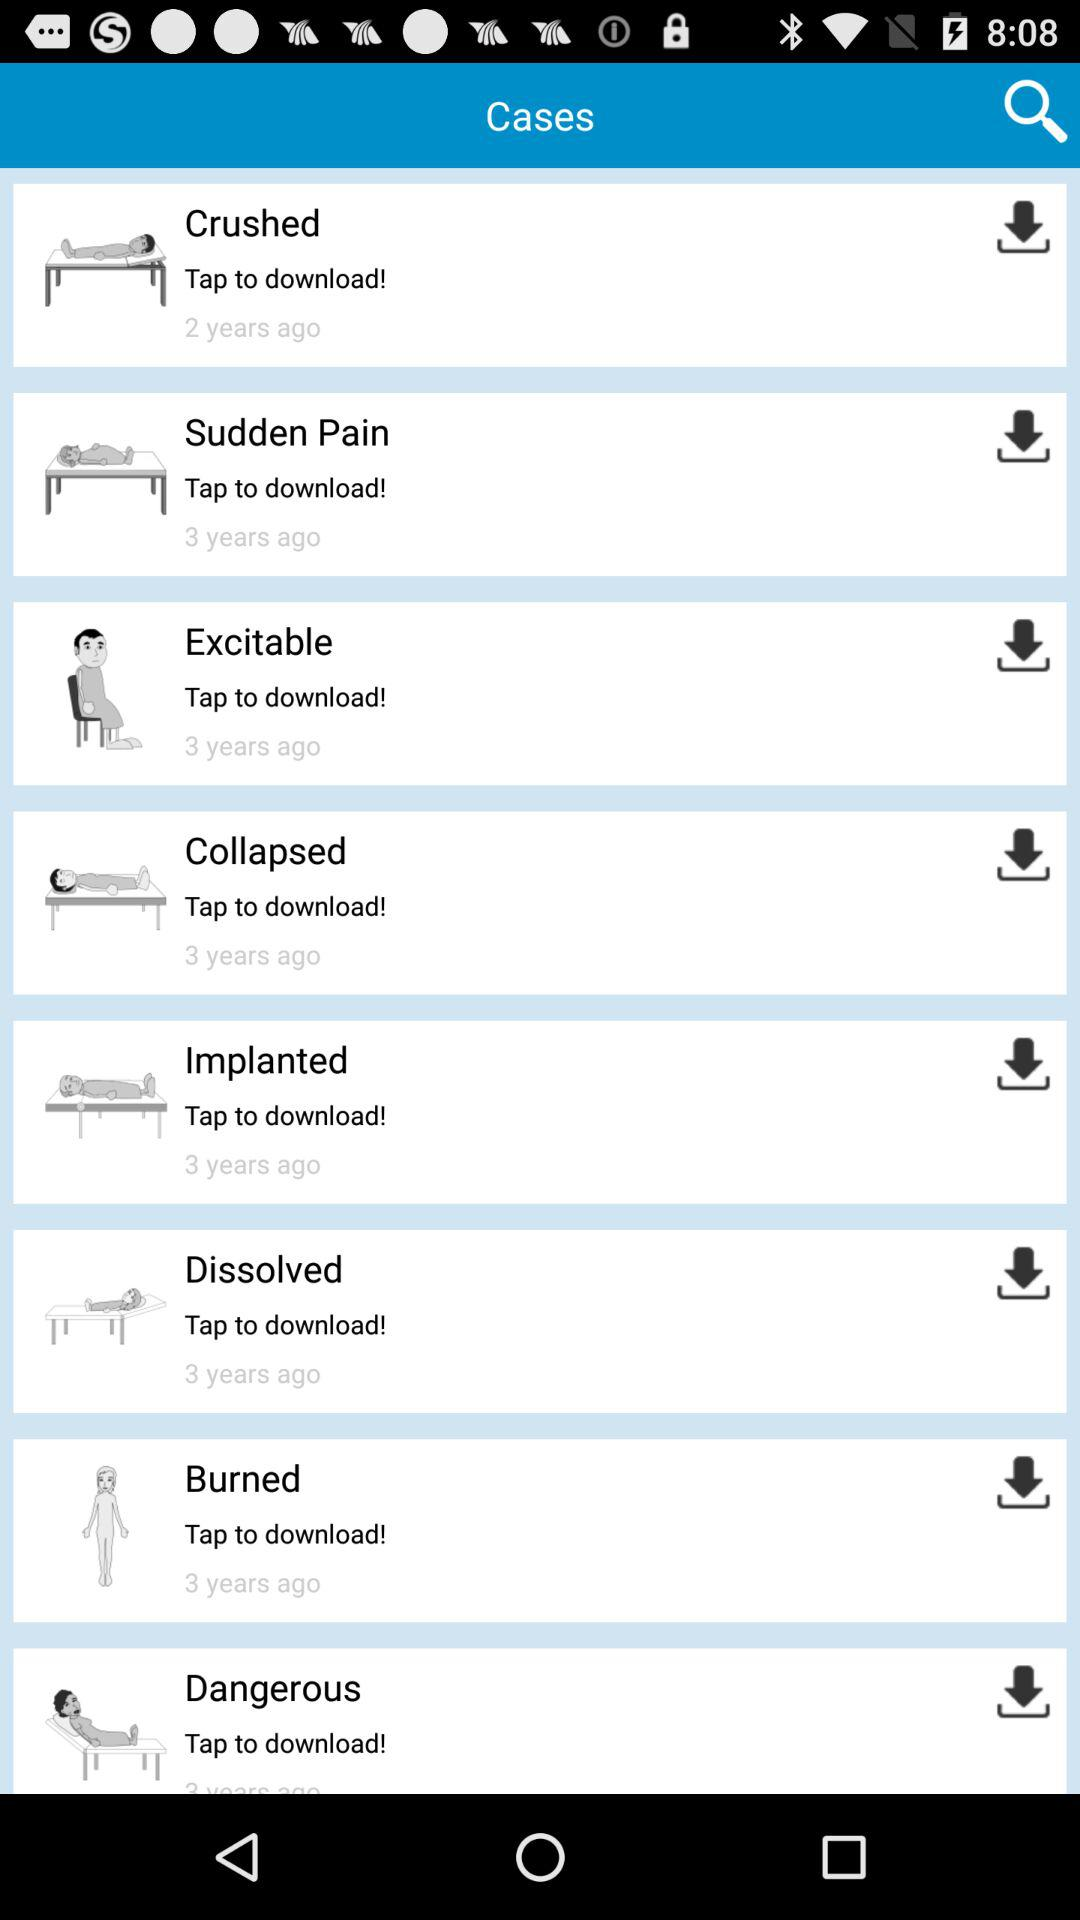What are the available cases? The available cases are "Crushed", "Sudden Pain", "Excitable", "Collapsed", "Implanted", "Dissolved", "Burned" and "Dangerous". 